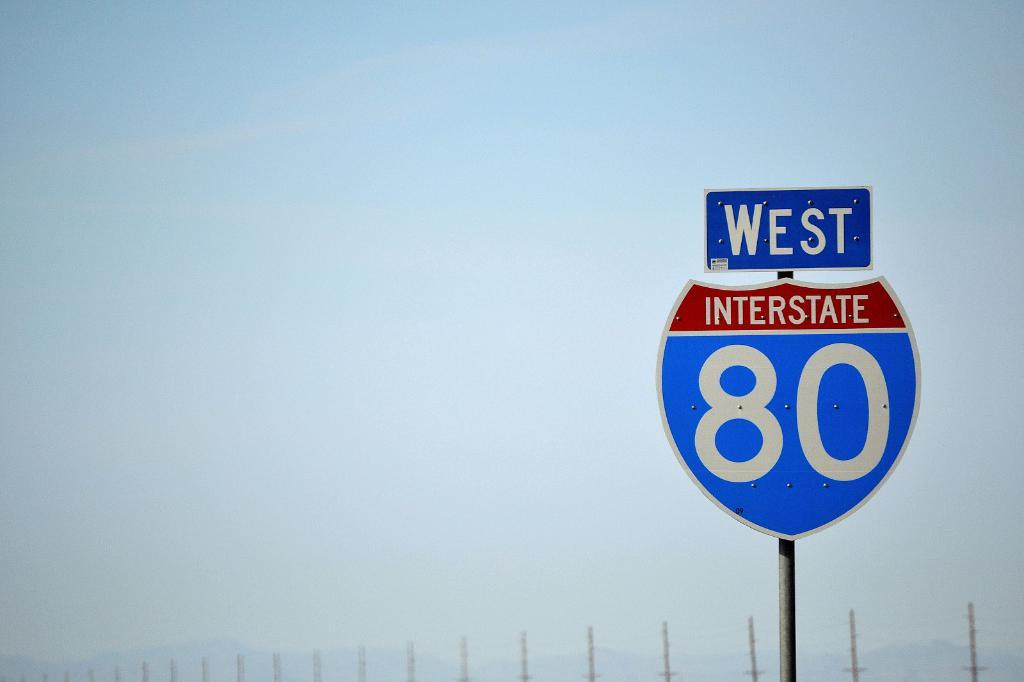<image>
Summarize the visual content of the image. A blue and red sign for West Interstate 80 